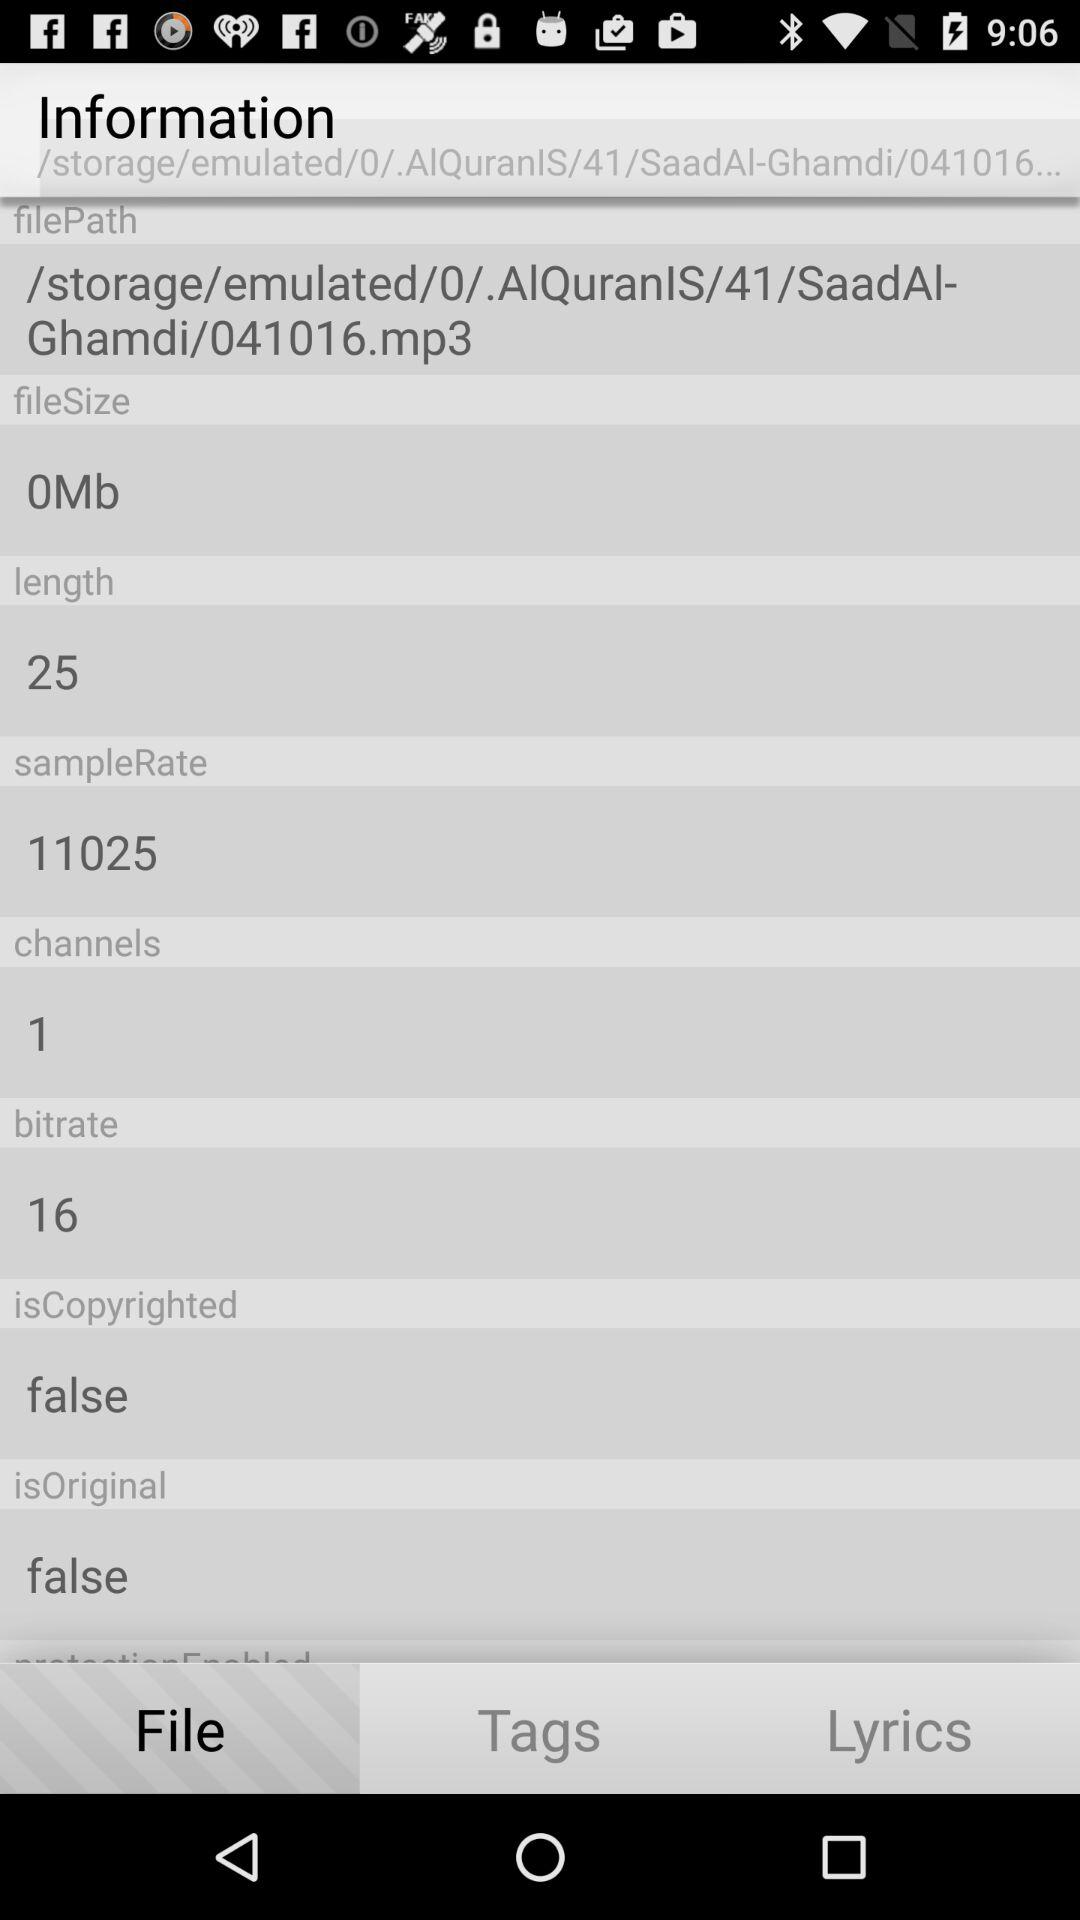What is the given length? The given length is 25. 